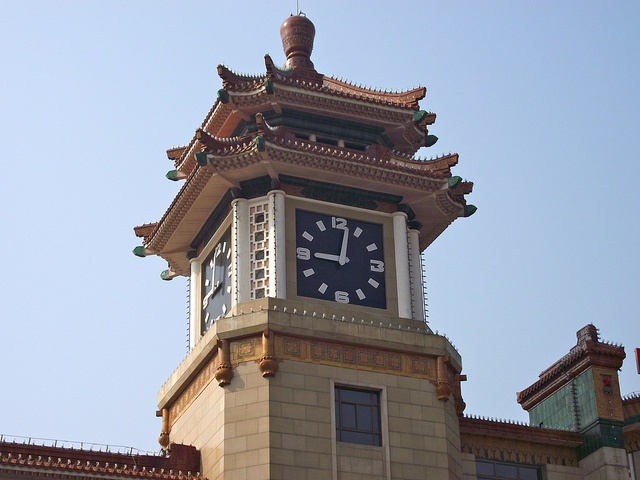Describe the objects in this image and their specific colors. I can see clock in lavender, black, and gray tones and clock in lavender, darkgray, gray, ivory, and tan tones in this image. 